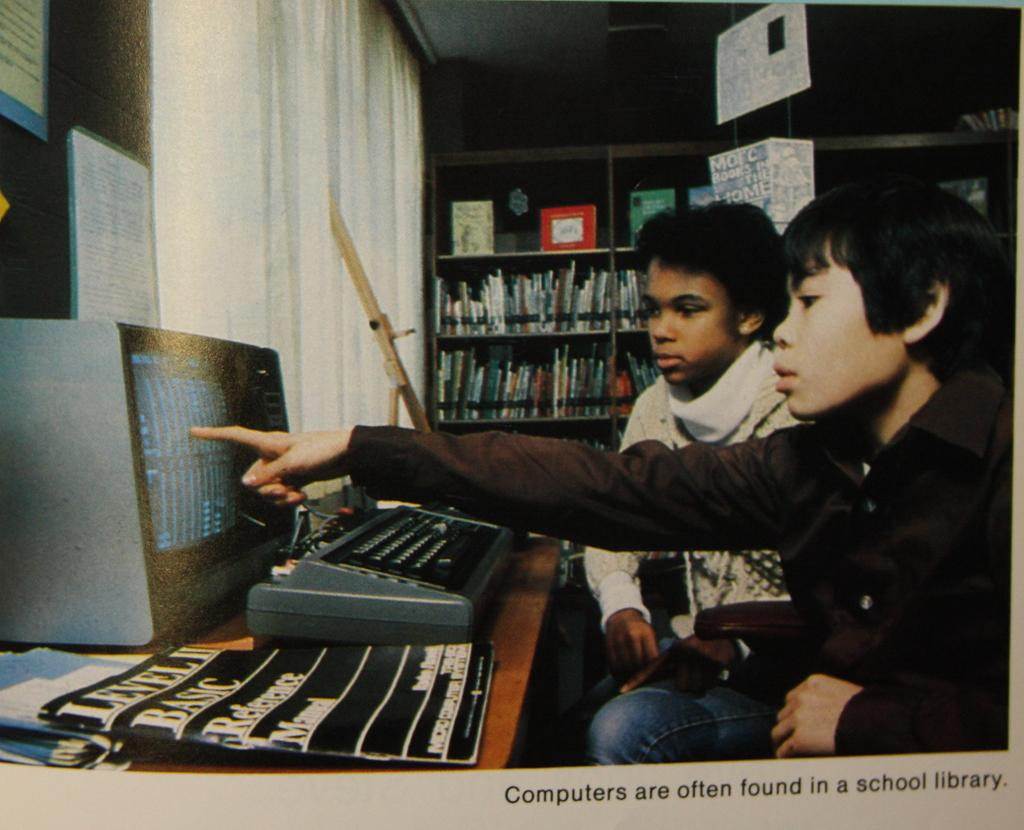<image>
Give a short and clear explanation of the subsequent image. A page of a magazine captioned "Computers are often found in a school library". 